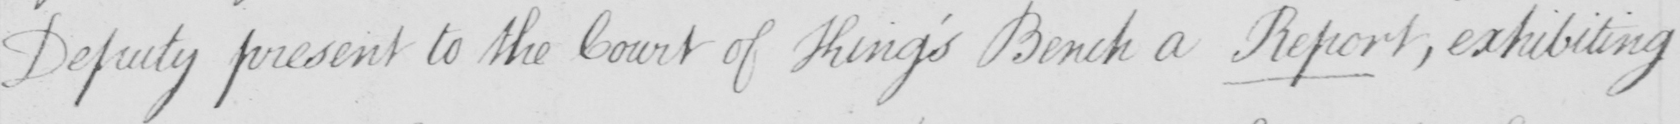Transcribe the text shown in this historical manuscript line. Deputy present to the Court of King ' s Bench a Report , exhibiting 